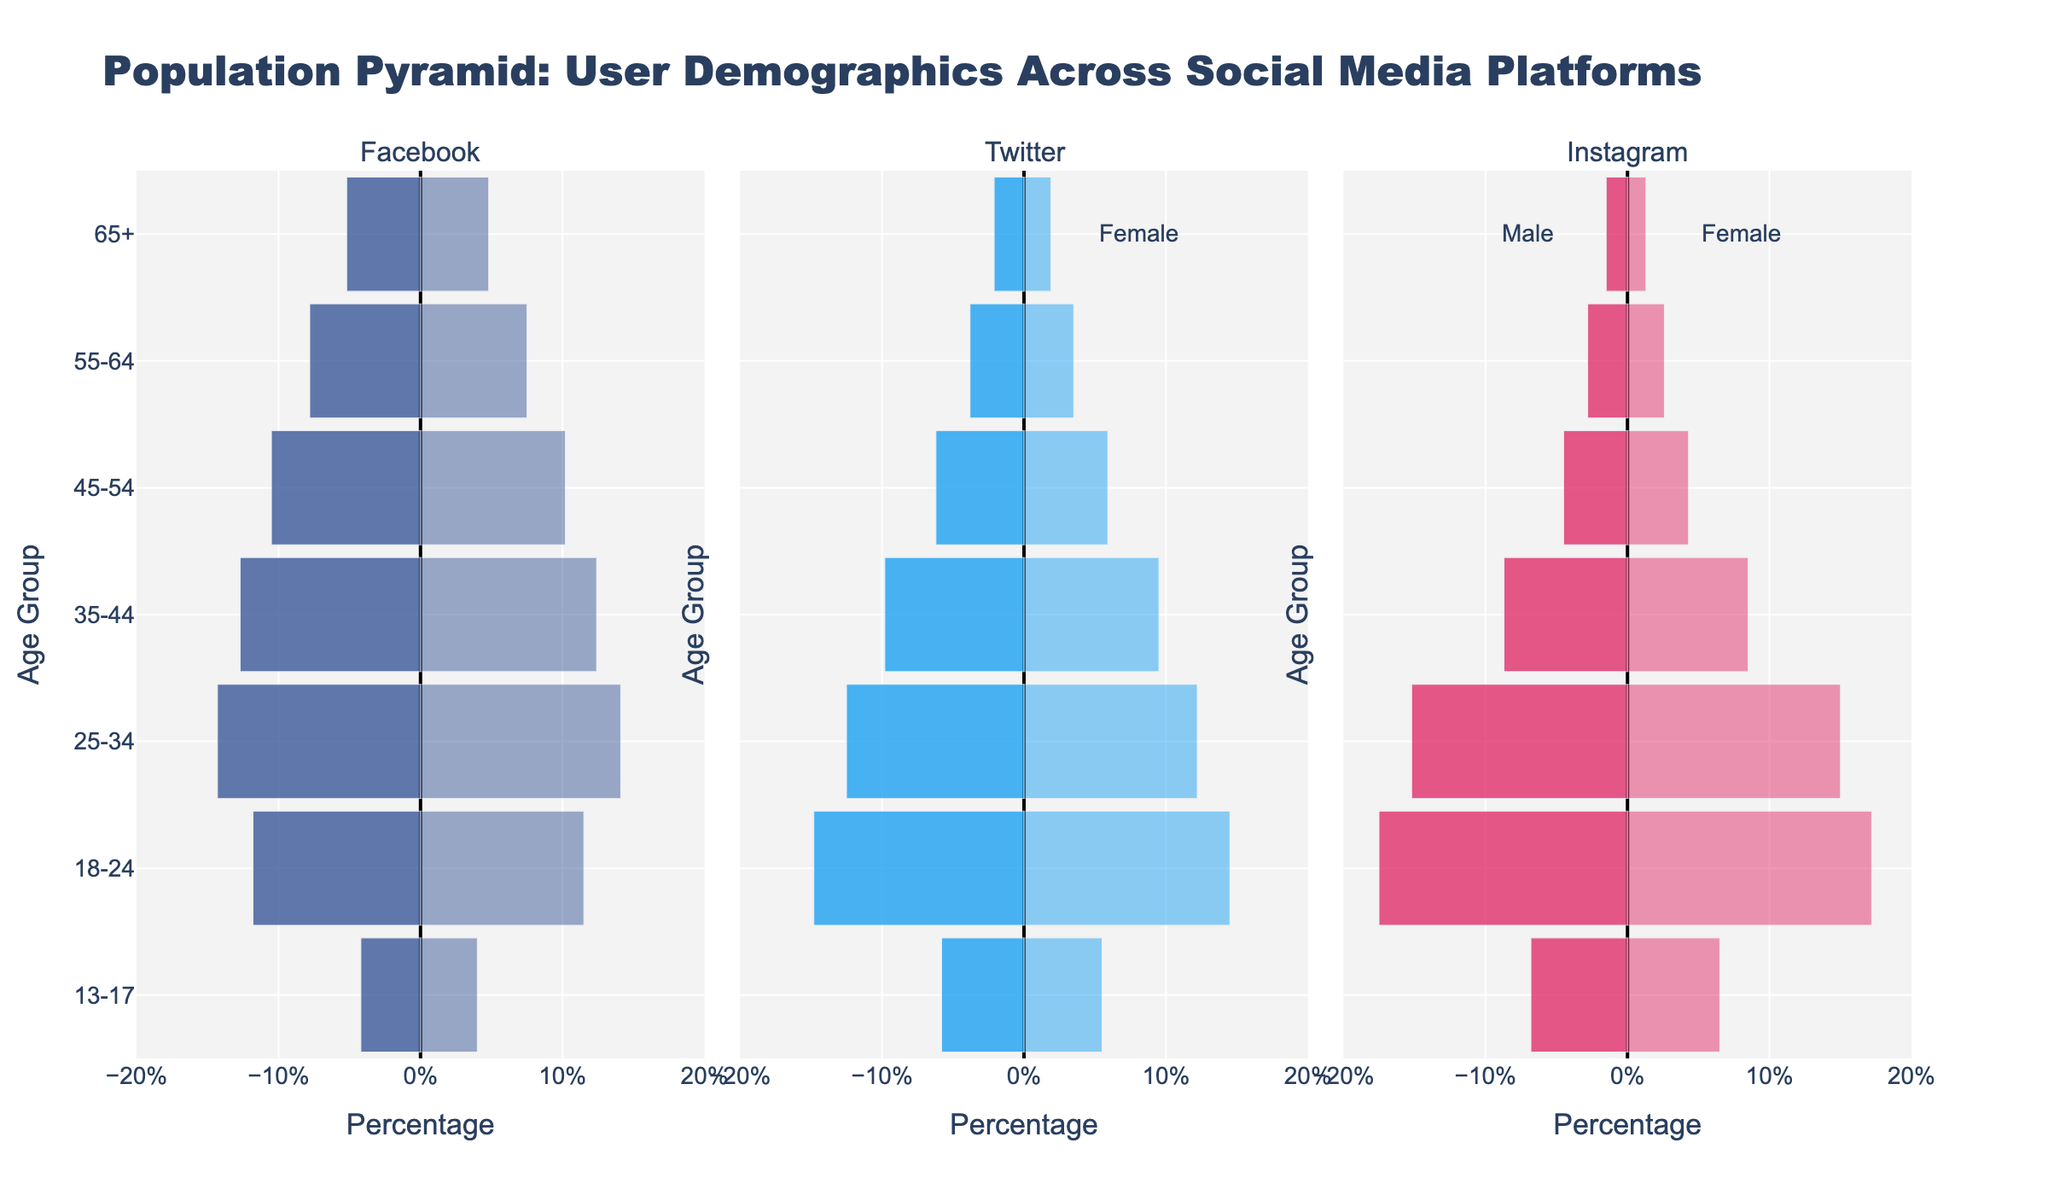What's the title of the figure? The title of the figure is located at the top and describes the overall theme of the visualization.
Answer: Population Pyramid: User Demographics Across Social Media Platforms Which age group has the highest percentage of Facebook users? The highest bars, both male and female, in the Facebook panel correspond to a specific age group, indicating the largest user base in that group. The 25-34 age group has the highest bars in the Facebook panel.
Answer: 25-34 In which age group is the gender difference most noticeable on Instagram? To find the gender difference, compare the male and female bars within each age group on the Instagram panel. The 25-34 age group shows the pronounced difference.
Answer: 25-34 What is the approximate percentage of female Twitter users aged 18-24? Locate the Twitter panel and find the bar representing females in the 18-24 age group.
Answer: 14.5% Compare the percentage of male Facebook users aged 35-44 to female Instagram users of the same age group. Which is higher? Look at the bars in both the Facebook and Instagram panels for the 35-44 age group and compare the male percentage on Facebook to the female percentage on Instagram. Male users on Facebook are 12.7%, and female users on Instagram are 8.5%. Therefore, the male percentage on Facebook is higher.
Answer: Facebook Male Which platform has the least number of elderly users (65+) for both genders combined? Sum the bars for both male and female users in the 65+ category for all three platforms. Facebook: 5.2+4.8=10, Twitter: 2.1+1.9=4, Instagram: 1.5+1.3=2.8. Instagram has the least number of elderly users.
Answer: Instagram What's the combined percentage of Twitter users aged 55-64? Add the male and female percentages for the 55-64 age group in the Twitter panel. 3.8% + 3.5% = 7.3%
Answer: 7.3% Which platform shows the most balanced gender distribution in the 18-24 age group? Compare the male and female bars for the 18-24 age group across all platforms. The platform with the smallest difference between male and female bars is the most balanced. Facebook: 11.8% (male) vs. 11.5% (female), Twitter: 14.8% vs. 14.5%, Instagram: 17.5% vs. 17.2%. All differences are very close, but Twitter has the smallest difference.
Answer: Twitter If we focus on the age group 13-17, which platform sees the highest percentage of user engagement for females? Look at the bar representing females in the 13-17 age group for all three platforms. Facebook Female: 4%, Twitter Female: 5.5%, Instagram Female: 6.5%. Instagram has the highest percentage.
Answer: Instagram What's the total combined user percentage across all platforms in the 45-54 age group for females? Sum the female user percentages in the 45-54 age group across Facebook, Twitter, and Instagram. Facebook: 10.2%, Twitter: 5.9%, Instagram: 4.3%. 10.2% + 5.9% + 4.3% = 20.4%
Answer: 20.4% 